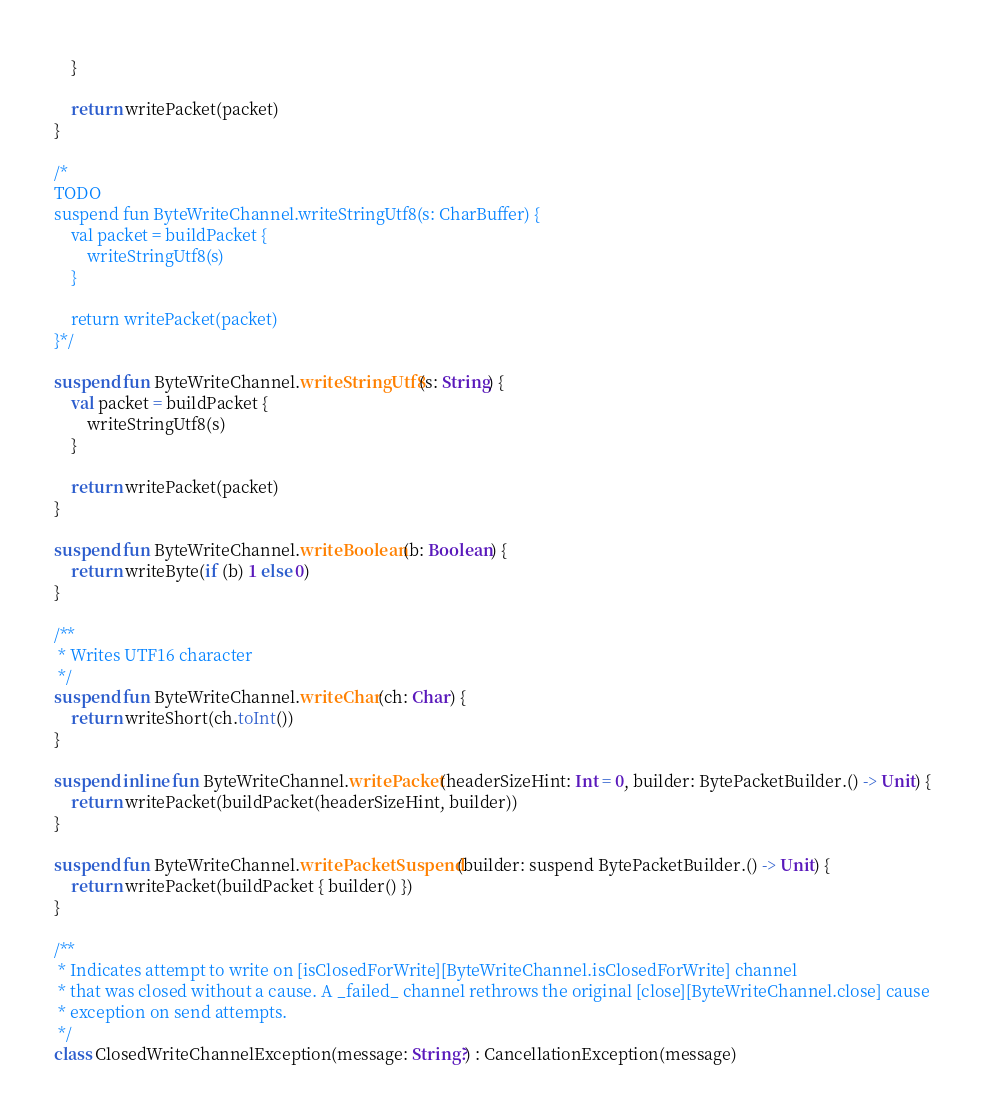Convert code to text. <code><loc_0><loc_0><loc_500><loc_500><_Kotlin_>    }

    return writePacket(packet)
}

/*
TODO
suspend fun ByteWriteChannel.writeStringUtf8(s: CharBuffer) {
    val packet = buildPacket {
        writeStringUtf8(s)
    }

    return writePacket(packet)
}*/

suspend fun ByteWriteChannel.writeStringUtf8(s: String) {
    val packet = buildPacket {
        writeStringUtf8(s)
    }

    return writePacket(packet)
}

suspend fun ByteWriteChannel.writeBoolean(b: Boolean) {
    return writeByte(if (b) 1 else 0)
}

/**
 * Writes UTF16 character
 */
suspend fun ByteWriteChannel.writeChar(ch: Char) {
    return writeShort(ch.toInt())
}

suspend inline fun ByteWriteChannel.writePacket(headerSizeHint: Int = 0, builder: BytePacketBuilder.() -> Unit) {
    return writePacket(buildPacket(headerSizeHint, builder))
}

suspend fun ByteWriteChannel.writePacketSuspend(builder: suspend BytePacketBuilder.() -> Unit) {
    return writePacket(buildPacket { builder() })
}

/**
 * Indicates attempt to write on [isClosedForWrite][ByteWriteChannel.isClosedForWrite] channel
 * that was closed without a cause. A _failed_ channel rethrows the original [close][ByteWriteChannel.close] cause
 * exception on send attempts.
 */
class ClosedWriteChannelException(message: String?) : CancellationException(message)

</code> 